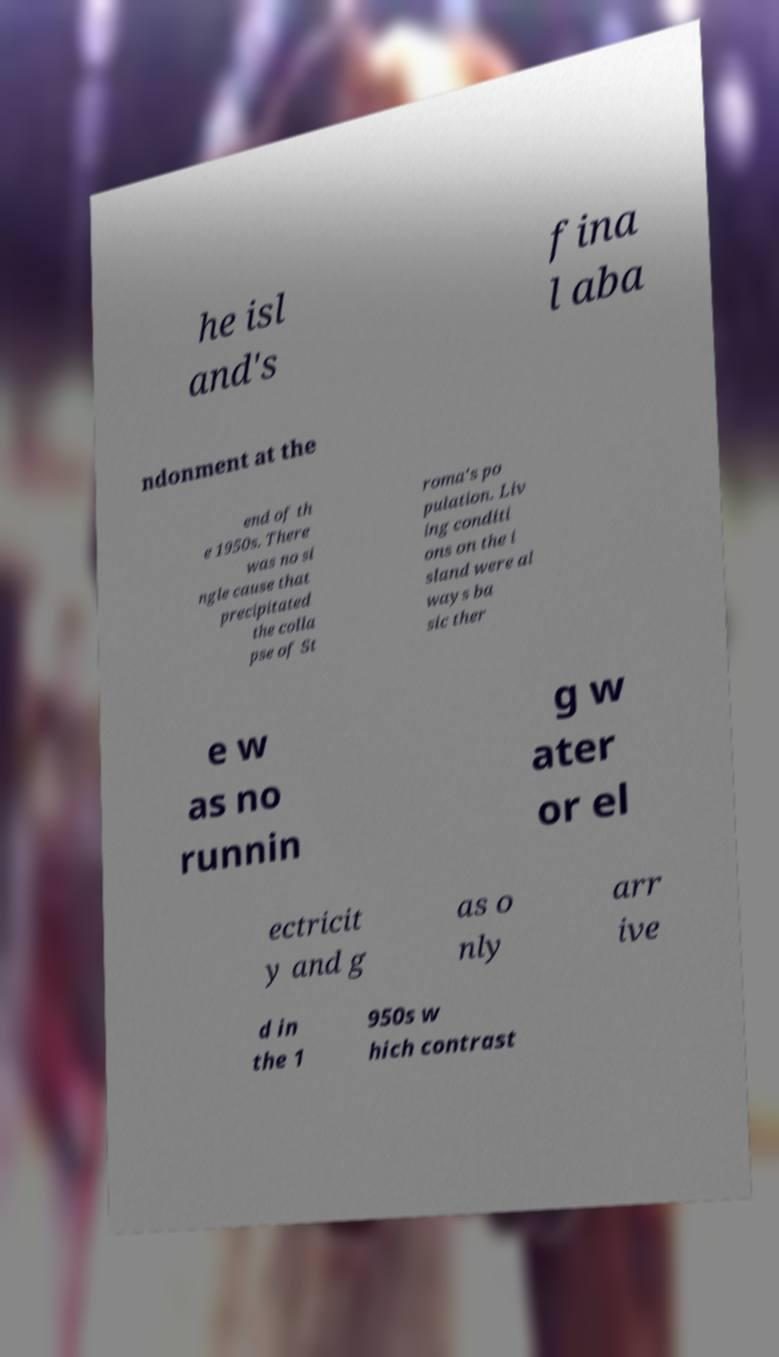Please identify and transcribe the text found in this image. he isl and's fina l aba ndonment at the end of th e 1950s. There was no si ngle cause that precipitated the colla pse of St roma's po pulation. Liv ing conditi ons on the i sland were al ways ba sic ther e w as no runnin g w ater or el ectricit y and g as o nly arr ive d in the 1 950s w hich contrast 